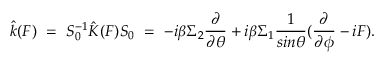<formula> <loc_0><loc_0><loc_500><loc_500>\hat { k } ( F ) = S _ { 0 } ^ { - 1 } \hat { K } ( F ) S _ { 0 } = - i \beta \Sigma _ { 2 } \frac { \partial } { \partial \theta } + i \beta \Sigma _ { 1 } \frac { 1 } { \sin \theta } ( \frac { \partial } { \partial \phi } - i F ) .</formula> 